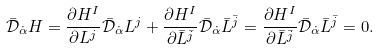Convert formula to latex. <formula><loc_0><loc_0><loc_500><loc_500>\bar { \mathcal { D } } _ { \dot { \alpha } } H = \frac { \partial H ^ { I } } { \partial L ^ { j } } \bar { \mathcal { D } } _ { \dot { \alpha } } L ^ { j } + \frac { \partial H ^ { I } } { \partial \bar { L } ^ { \bar { j } } } \bar { \mathcal { D } } _ { \dot { \alpha } } \bar { L } ^ { \bar { j } } = \frac { \partial H ^ { I } } { \partial \bar { L } ^ { \bar { j } } } \bar { \mathcal { D } } _ { \dot { \alpha } } \bar { L } ^ { \bar { j } } = 0 .</formula> 